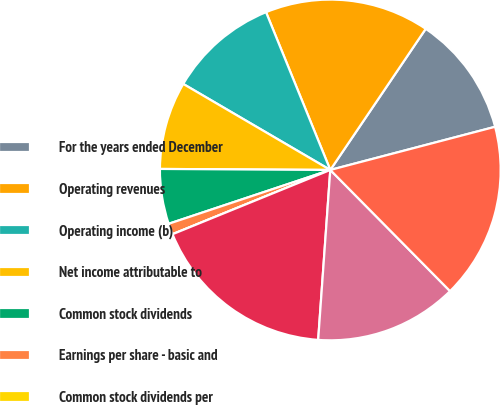Convert chart to OTSL. <chart><loc_0><loc_0><loc_500><loc_500><pie_chart><fcel>For the years ended December<fcel>Operating revenues<fcel>Operating income (b)<fcel>Net income attributable to<fcel>Common stock dividends<fcel>Earnings per share - basic and<fcel>Common stock dividends per<fcel>Total assets<fcel>Long-term debt excluding<fcel>Total Ameren Corporation<nl><fcel>11.46%<fcel>15.62%<fcel>10.42%<fcel>8.33%<fcel>5.21%<fcel>1.04%<fcel>0.0%<fcel>17.71%<fcel>13.54%<fcel>16.67%<nl></chart> 